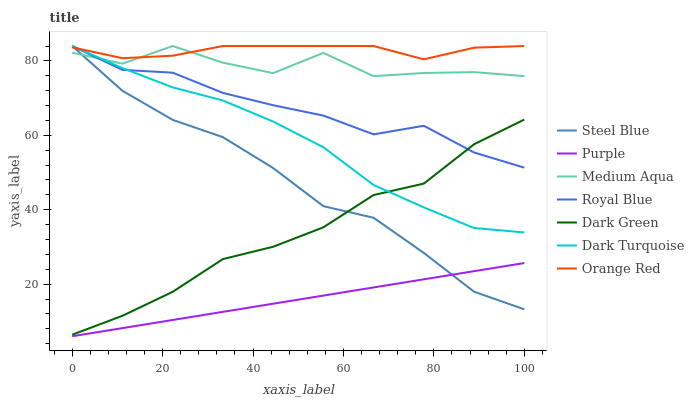Does Purple have the minimum area under the curve?
Answer yes or no. Yes. Does Orange Red have the maximum area under the curve?
Answer yes or no. Yes. Does Dark Turquoise have the minimum area under the curve?
Answer yes or no. No. Does Dark Turquoise have the maximum area under the curve?
Answer yes or no. No. Is Purple the smoothest?
Answer yes or no. Yes. Is Medium Aqua the roughest?
Answer yes or no. Yes. Is Dark Turquoise the smoothest?
Answer yes or no. No. Is Dark Turquoise the roughest?
Answer yes or no. No. Does Purple have the lowest value?
Answer yes or no. Yes. Does Dark Turquoise have the lowest value?
Answer yes or no. No. Does Orange Red have the highest value?
Answer yes or no. Yes. Does Dark Green have the highest value?
Answer yes or no. No. Is Purple less than Dark Green?
Answer yes or no. Yes. Is Orange Red greater than Purple?
Answer yes or no. Yes. Does Orange Red intersect Royal Blue?
Answer yes or no. Yes. Is Orange Red less than Royal Blue?
Answer yes or no. No. Is Orange Red greater than Royal Blue?
Answer yes or no. No. Does Purple intersect Dark Green?
Answer yes or no. No. 